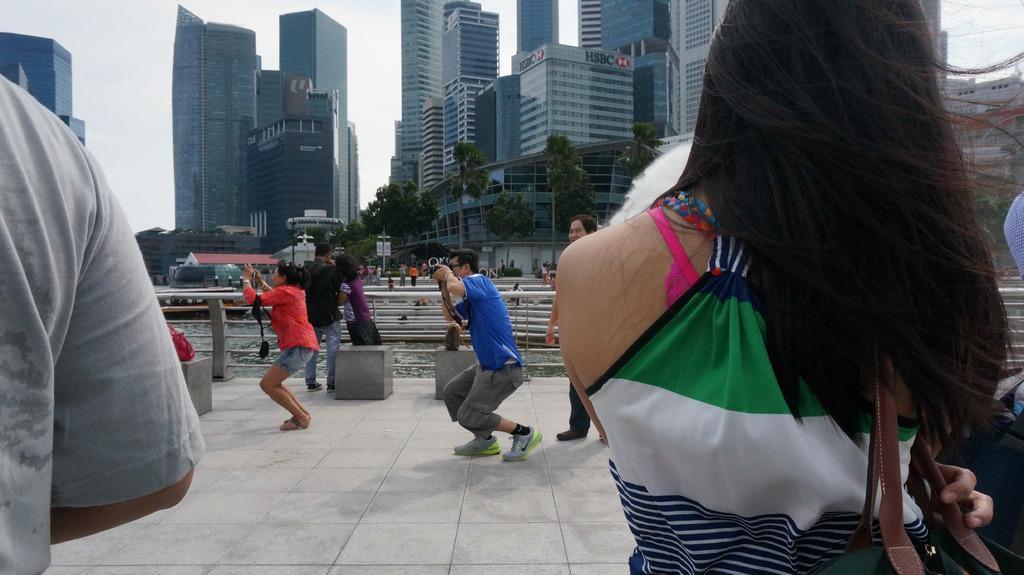Can you describe this image briefly? In this image, we can see few people. Few people are holding cameras. At the bottom, there is a walkway. Background there are so many trees, buildings, poles, water, railing and sky. 